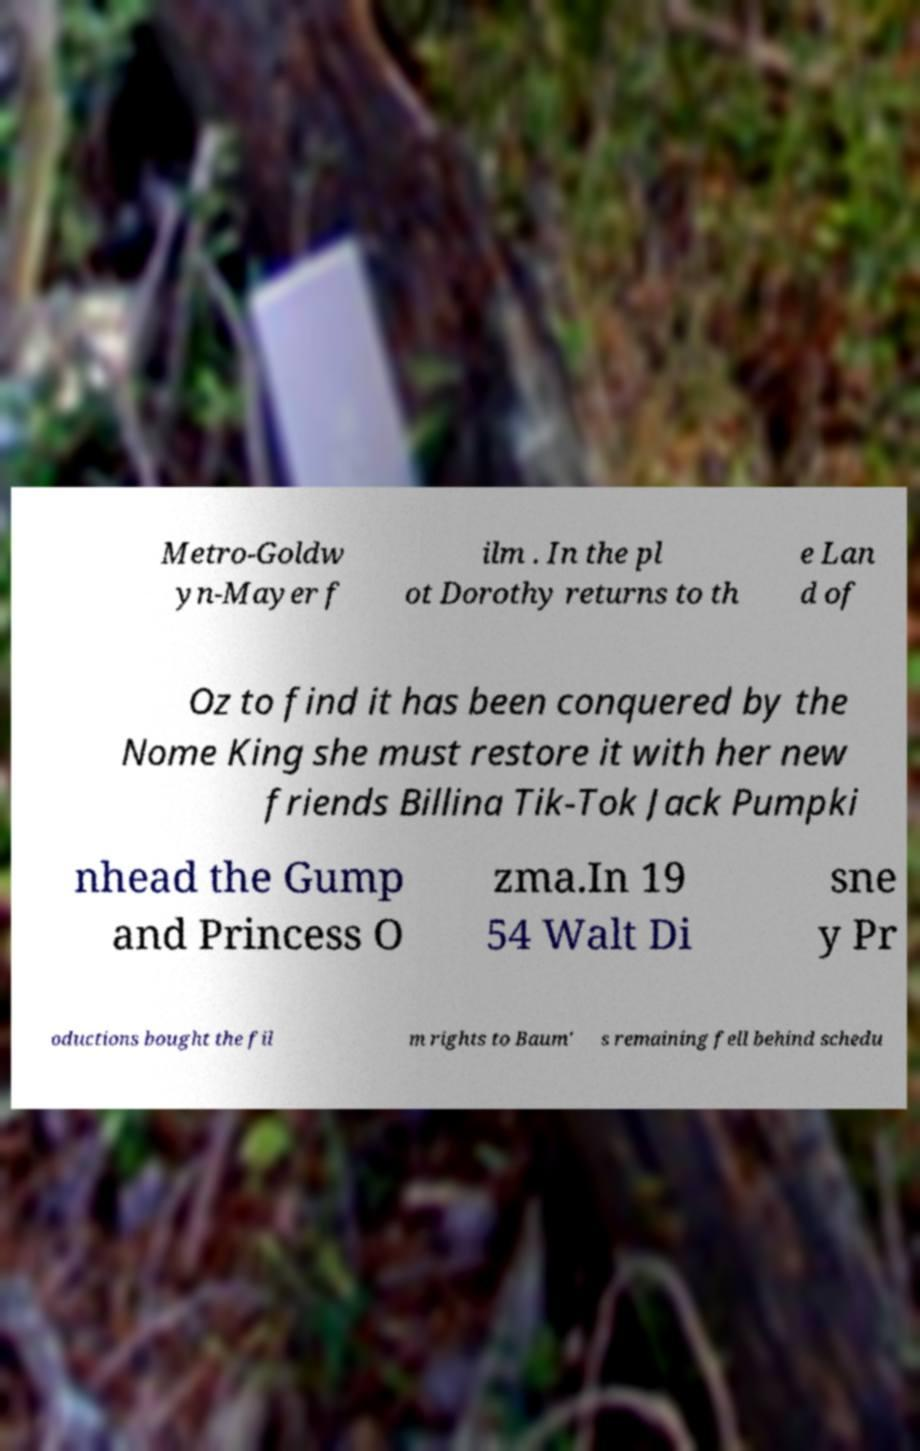I need the written content from this picture converted into text. Can you do that? Metro-Goldw yn-Mayer f ilm . In the pl ot Dorothy returns to th e Lan d of Oz to find it has been conquered by the Nome King she must restore it with her new friends Billina Tik-Tok Jack Pumpki nhead the Gump and Princess O zma.In 19 54 Walt Di sne y Pr oductions bought the fil m rights to Baum' s remaining fell behind schedu 